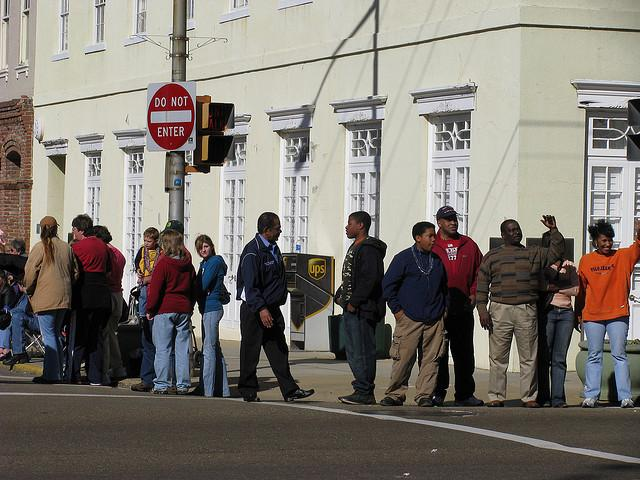What is under the red and white sign?

Choices:
A) boy
B) polar bear
C) seal
D) cat boy 